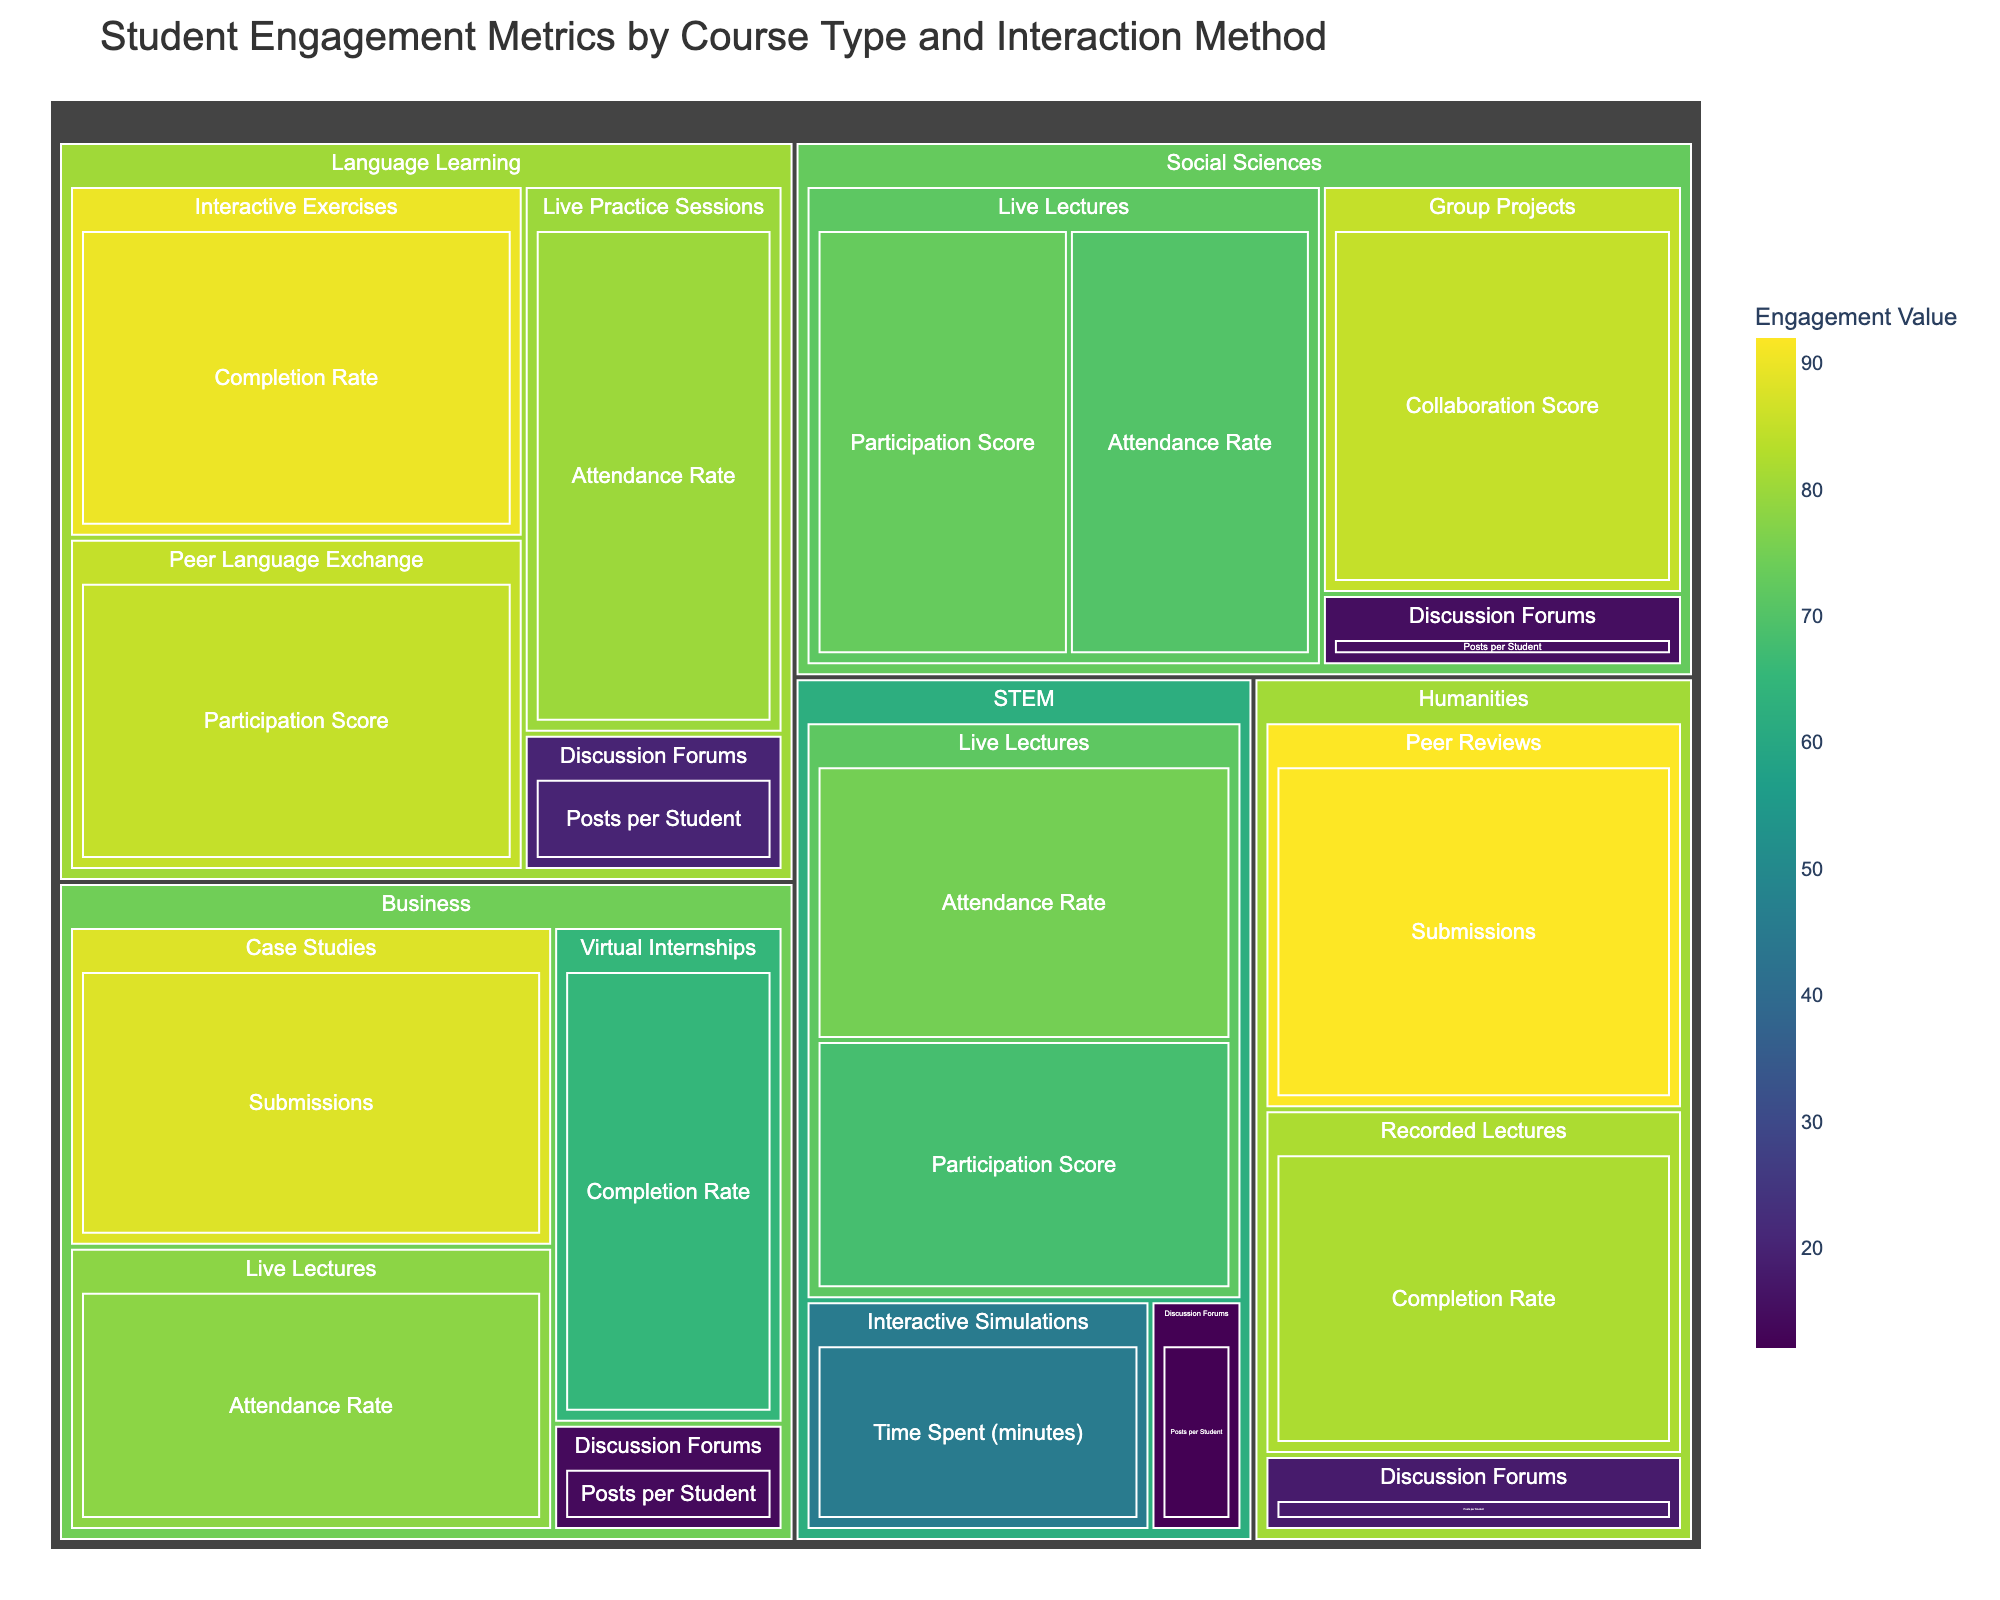What is the attendance rate for STEM live lectures? The treemap shows the "STEM" section under "Live Lectures" and the engagement metric "Attendance Rate" with a value.
Answer: 75 Which interaction method in Humanities has the highest value? In the Humanities section, compare the values for each interaction method: Recorded Lectures (82), Discussion Forums (18), Peer Reviews (92). The highest value is for Peer Reviews.
Answer: Peer Reviews What is the average attendance rate for live lectures across all courses? Identify the values for "Live Lectures" in each course type (STEM: 75, Social Sciences: 70, Business: 78). Calculate their average: (75 + 70 + 78) / 3 = 74.33.
Answer: 74.33 Which course type has the most engagement in discussion forums in terms of posts per student? Compare the "Posts per Student" values in the "Discussion Forums" for each course type: STEM (12), Humanities (18), Social Sciences (15), Business (14), Language Learning (20). The highest value is for Language Learning.
Answer: Language Learning What interaction method in Social Sciences has the highest engagement metric value? Look at the metrics in the Social Sciences section. The values are for Live Lectures Attendance Rate (70), Live Lectures Participation Score (73), Group Projects Collaboration Score (85), and Discussion Forums Posts per Student (15). The highest value is Group Projects Collaboration Score.
Answer: Group Projects What is the difference in attendance rates between Business and Social Sciences live lectures? Subtract the attendance rate of Social Sciences live lectures from that of Business live lectures: 78 - 70.
Answer: 8 Which course type has the highest overall engagement value across all interaction methods? Identify the highest value for each course type: STEM (75), Humanities (92), Social Sciences (85), Business (88), Language Learning (90). The highest overall engagement value is in Humanities (92).
Answer: Humanities How does the completion rate for recorded lectures in Humanities compare to the completion rate for virtual internships in Business? Compare the two completion rates: Humanities recorded lectures (82) and Business virtual internships (65). The completion rate for Humanities recorded lectures is higher.
Answer: Higher in Humanities What is the participation score for peer language exchange in Language Learning? Locate the "Peer Language Exchange" under "Language Learning" and find the participation score value.
Answer: 85 How many posts per student are there in STEM discussion forums? Locate the "Discussion Forums" under "STEM" and find the value for "Posts per Student".
Answer: 12 